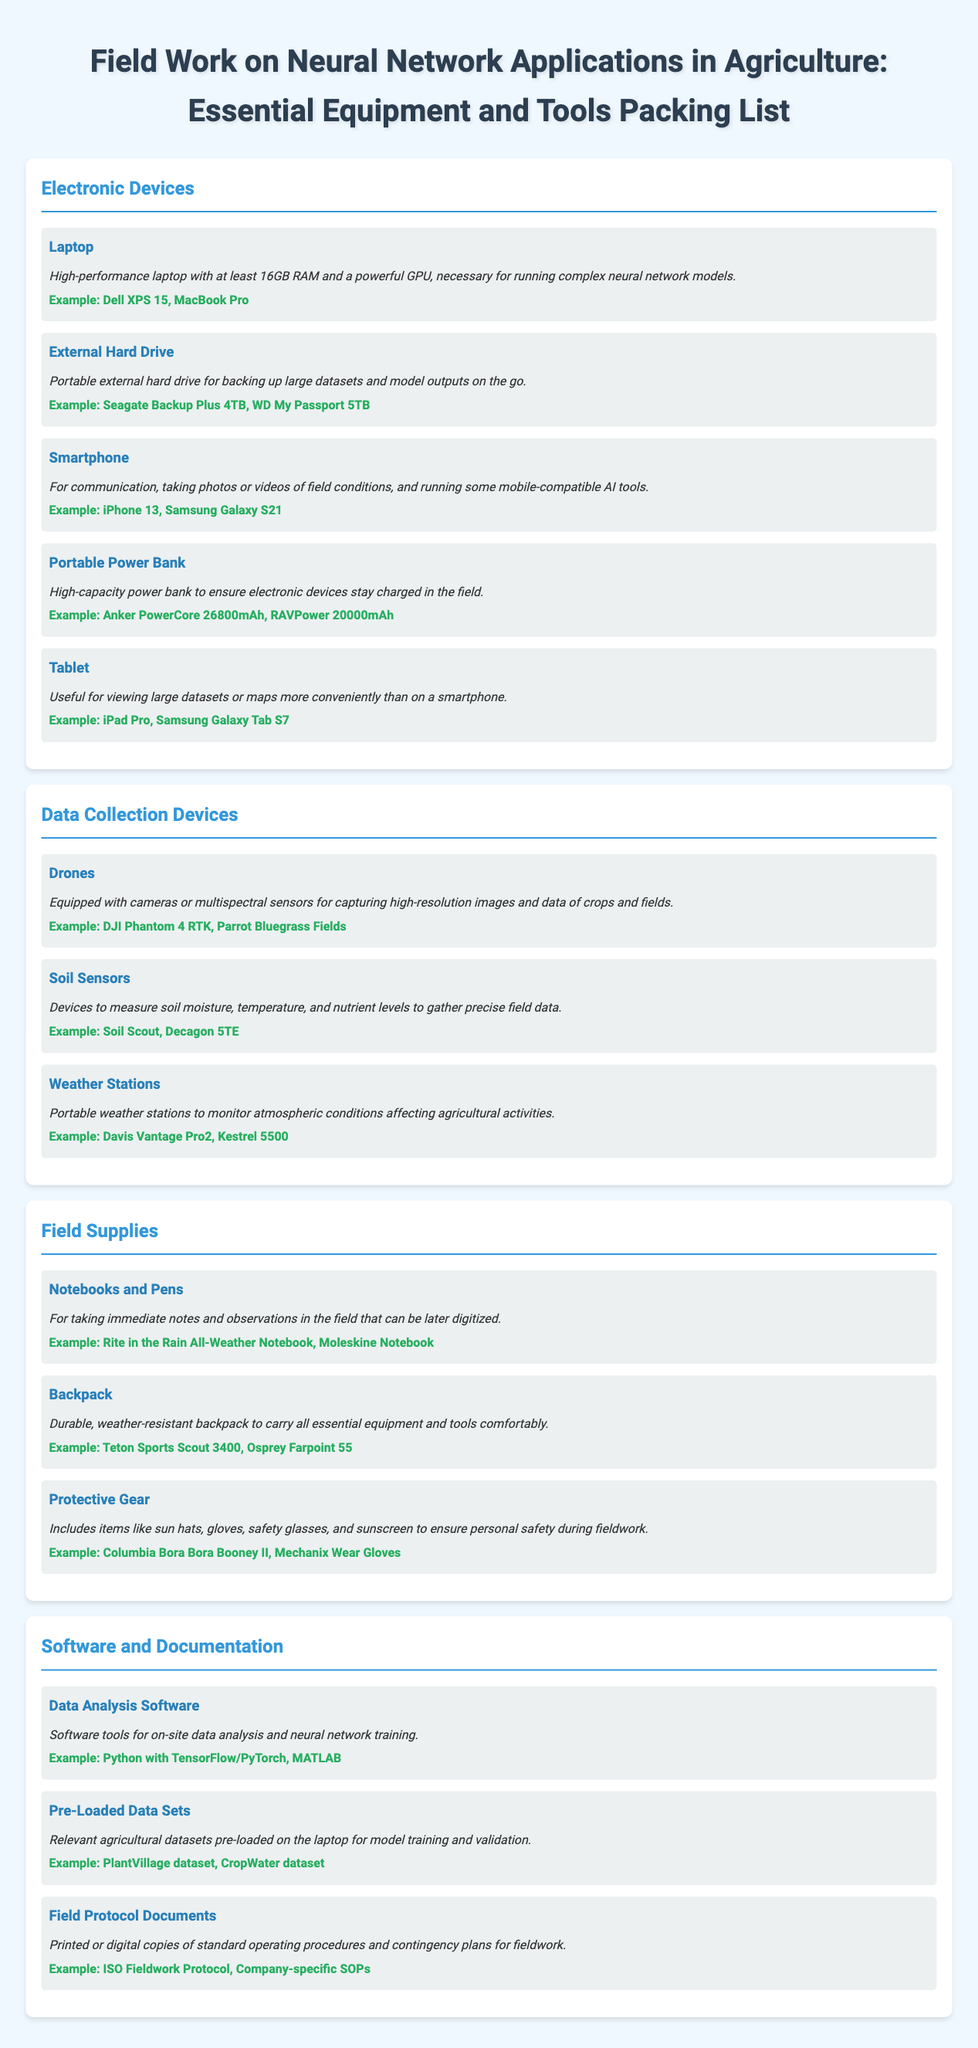What is the minimum RAM required for the laptop? The document specifies that the laptop must have at least 16GB RAM.
Answer: 16GB Name an example of a portable power bank. The document provides an example of a portable power bank as Anker PowerCore 26800mAh.
Answer: Anker PowerCore 26800mAh What type of soil data can soil sensors measure? Soil sensors measure soil moisture, temperature, and nutrient levels.
Answer: Moisture, temperature, nutrient levels What are essential items included in protective gear? The document mentions sun hats, gloves, safety glasses, and sunscreen as part of protective gear.
Answer: Sun hats, gloves, safety glasses, sunscreen Which software is recommended for on-site data analysis? The document suggests using Python with TensorFlow/PyTorch for on-site data analysis.
Answer: Python with TensorFlow/PyTorch How many categories are listed in the packing list? There are four categories outlined in the packing list document.
Answer: Four 